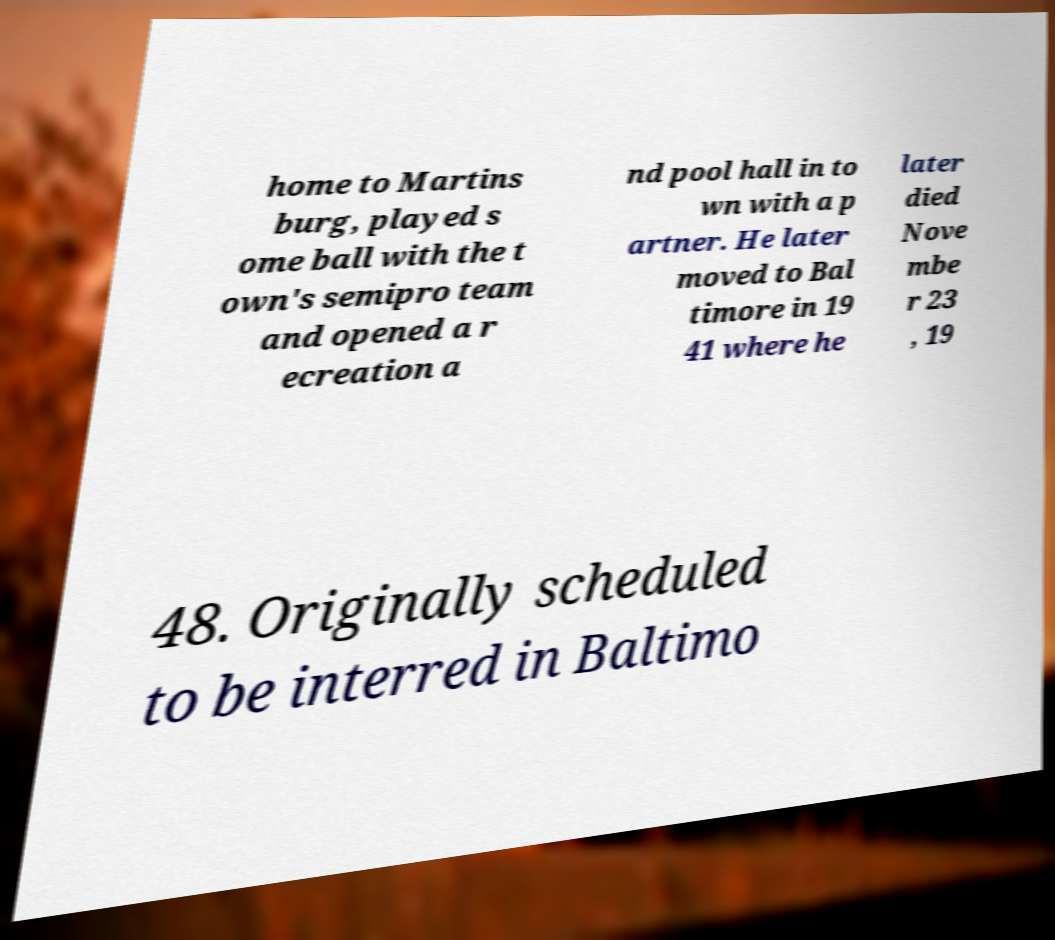Could you assist in decoding the text presented in this image and type it out clearly? home to Martins burg, played s ome ball with the t own's semipro team and opened a r ecreation a nd pool hall in to wn with a p artner. He later moved to Bal timore in 19 41 where he later died Nove mbe r 23 , 19 48. Originally scheduled to be interred in Baltimo 